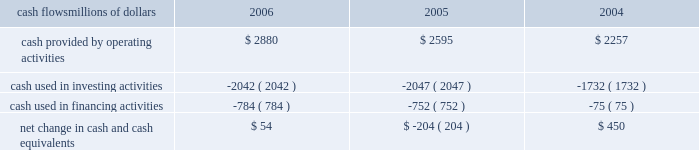Liquidity and capital resources as of december 31 , 2006 , our principal sources of liquidity included cash , cash equivalents , the sale of receivables , and our revolving credit facilities , as well as the availability of commercial paper and other sources of financing through the capital markets .
We had $ 2 billion of committed credit facilities available , of which there were no borrowings outstanding as of december 31 , 2006 , and we did not make any short-term borrowings under these facilities during the year .
The value of the outstanding undivided interest held by investors under the sale of receivables program was $ 600 million as of december 31 , 2006 .
The sale of receivables program is subject to certain requirements , including the maintenance of an investment grade bond rating .
If our bond rating were to deteriorate , it could have an adverse impact on our liquidity .
Access to commercial paper is dependent on market conditions .
Deterioration of our operating results or financial condition due to internal or external factors could negatively impact our ability to utilize commercial paper as a source of liquidity .
Liquidity through the capital markets is also dependent on our financial stability .
At both december 31 , 2006 and 2005 , we had a working capital deficit of approximately $ 1.1 billion .
A working capital deficit is common in our industry and does not indicate a lack of liquidity .
We maintain adequate resources to meet our daily cash requirements , and we have sufficient financial capacity to satisfy our current liabilities .
Financial condition cash flows millions of dollars 2006 2005 2004 .
Cash provided by operating activities 2013 higher income in 2006 generated the increased cash provided by operating activities , which was partially offset by higher income tax payments , $ 150 million in voluntary pension contributions , higher material and supply inventories , and higher management incentive payments in 2006 .
Higher income , lower management incentive payments in 2005 ( executive bonuses , which would have been paid to individuals in 2005 , were not awarded based on company performance in 2004 and bonuses for the professional workforce that were paid out in 2005 were significantly reduced ) , and working capital performance generated higher cash from operating activities in 2005 .
A voluntary pension contribution of $ 100 million in 2004 also augmented the positive year-over-year variance in 2005 as no pension contribution was made in 2005 .
This improvement was partially offset by cash received in 2004 for income tax refunds .
Cash used in investing activities 2013 an insurance settlement for the 2005 january west coast storm and lower balances for work in process decreased the amount of cash used in investing activities in 2006 .
Higher capital investments and lower proceeds from asset sales partially offset this decrease .
Increased capital spending , partially offset by higher proceeds from asset sales , increased the amount of cash used in investing activities in 2005 compared to 2004 .
Cash used in financing activities 2013 the increase in cash used in financing activities primarily resulted from lower net proceeds from equity compensation plans ( $ 189 million in 2006 compared to $ 262 million in 2005 ) .
The increase in 2005 results from debt issuances in 2004 and higher debt repayments in 2005 .
We did not issue debt in 2005 versus $ 745 million of debt issuances in 2004 , and we repaid $ 699 million of debt in 2005 compared to $ 588 million in 2004 .
The higher outflows in 2005 were partially offset by higher net proceeds from equity compensation plans ( $ 262 million in 2005 compared to $ 80 million in 2004 ) . .
In 2005 what was the ratio of the cash used in investments activities to the financing activities? 
Computations: (2047 / 752)
Answer: 2.72207. Liquidity and capital resources as of december 31 , 2006 , our principal sources of liquidity included cash , cash equivalents , the sale of receivables , and our revolving credit facilities , as well as the availability of commercial paper and other sources of financing through the capital markets .
We had $ 2 billion of committed credit facilities available , of which there were no borrowings outstanding as of december 31 , 2006 , and we did not make any short-term borrowings under these facilities during the year .
The value of the outstanding undivided interest held by investors under the sale of receivables program was $ 600 million as of december 31 , 2006 .
The sale of receivables program is subject to certain requirements , including the maintenance of an investment grade bond rating .
If our bond rating were to deteriorate , it could have an adverse impact on our liquidity .
Access to commercial paper is dependent on market conditions .
Deterioration of our operating results or financial condition due to internal or external factors could negatively impact our ability to utilize commercial paper as a source of liquidity .
Liquidity through the capital markets is also dependent on our financial stability .
At both december 31 , 2006 and 2005 , we had a working capital deficit of approximately $ 1.1 billion .
A working capital deficit is common in our industry and does not indicate a lack of liquidity .
We maintain adequate resources to meet our daily cash requirements , and we have sufficient financial capacity to satisfy our current liabilities .
Financial condition cash flows millions of dollars 2006 2005 2004 .
Cash provided by operating activities 2013 higher income in 2006 generated the increased cash provided by operating activities , which was partially offset by higher income tax payments , $ 150 million in voluntary pension contributions , higher material and supply inventories , and higher management incentive payments in 2006 .
Higher income , lower management incentive payments in 2005 ( executive bonuses , which would have been paid to individuals in 2005 , were not awarded based on company performance in 2004 and bonuses for the professional workforce that were paid out in 2005 were significantly reduced ) , and working capital performance generated higher cash from operating activities in 2005 .
A voluntary pension contribution of $ 100 million in 2004 also augmented the positive year-over-year variance in 2005 as no pension contribution was made in 2005 .
This improvement was partially offset by cash received in 2004 for income tax refunds .
Cash used in investing activities 2013 an insurance settlement for the 2005 january west coast storm and lower balances for work in process decreased the amount of cash used in investing activities in 2006 .
Higher capital investments and lower proceeds from asset sales partially offset this decrease .
Increased capital spending , partially offset by higher proceeds from asset sales , increased the amount of cash used in investing activities in 2005 compared to 2004 .
Cash used in financing activities 2013 the increase in cash used in financing activities primarily resulted from lower net proceeds from equity compensation plans ( $ 189 million in 2006 compared to $ 262 million in 2005 ) .
The increase in 2005 results from debt issuances in 2004 and higher debt repayments in 2005 .
We did not issue debt in 2005 versus $ 745 million of debt issuances in 2004 , and we repaid $ 699 million of debt in 2005 compared to $ 588 million in 2004 .
The higher outflows in 2005 were partially offset by higher net proceeds from equity compensation plans ( $ 262 million in 2005 compared to $ 80 million in 2004 ) . .
What was the ratio of the debt issue in 2004 to the debt payment in 2005? 
Rationale: for every $ 1.1 of debt issued in 2004 $ 1 was paid in 2005
Computations: (745 / 699)
Answer: 1.06581. 